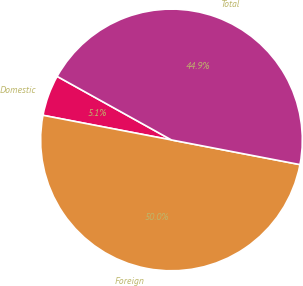Convert chart to OTSL. <chart><loc_0><loc_0><loc_500><loc_500><pie_chart><fcel>Domestic<fcel>Foreign<fcel>Total<nl><fcel>5.06%<fcel>50.0%<fcel>44.94%<nl></chart> 